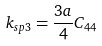<formula> <loc_0><loc_0><loc_500><loc_500>k _ { s p 3 } = \frac { 3 a } { 4 } C _ { 4 4 }</formula> 